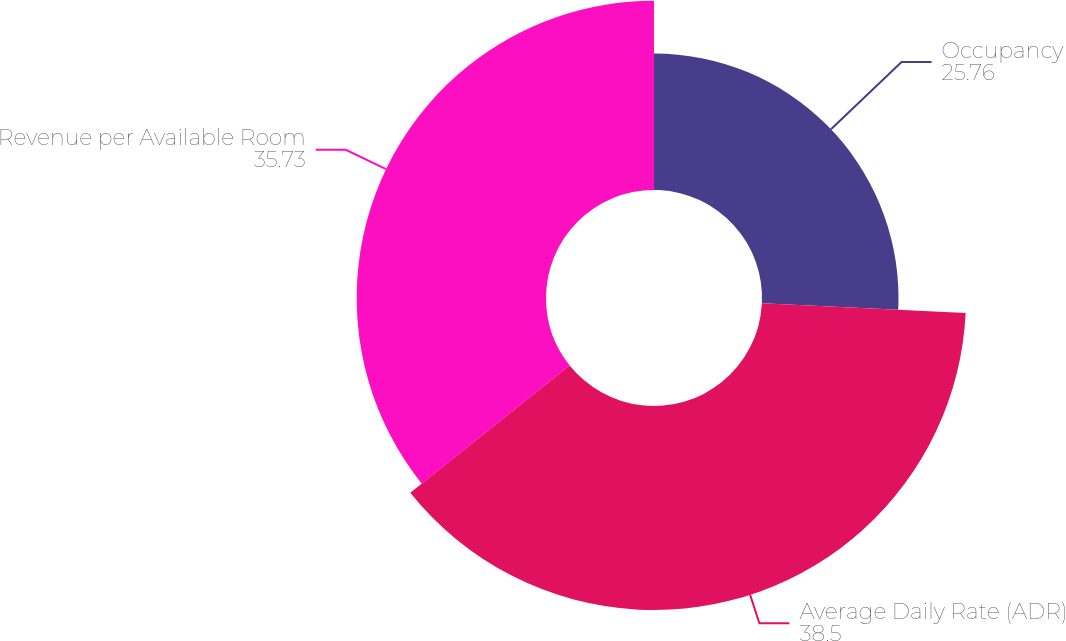Convert chart to OTSL. <chart><loc_0><loc_0><loc_500><loc_500><pie_chart><fcel>Occupancy<fcel>Average Daily Rate (ADR)<fcel>Revenue per Available Room<nl><fcel>25.76%<fcel>38.5%<fcel>35.73%<nl></chart> 